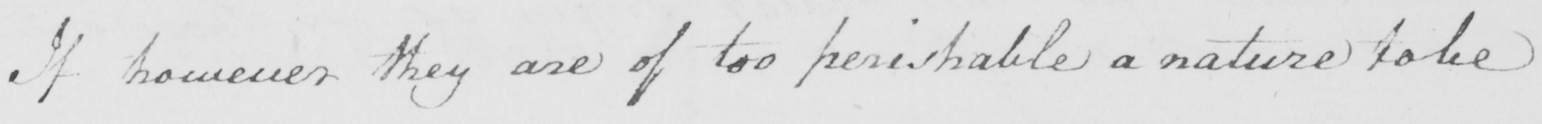Transcribe the text shown in this historical manuscript line. If however they are of too perishable a nature to be 